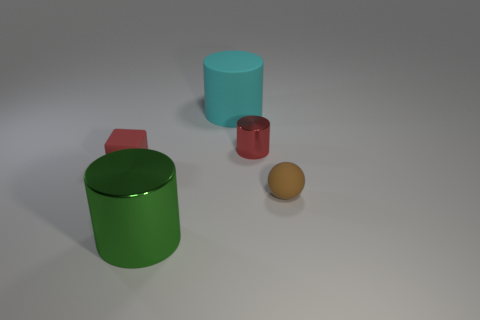Add 3 red blocks. How many objects exist? 8 Subtract all blocks. How many objects are left? 4 Subtract 0 yellow cubes. How many objects are left? 5 Subtract all red shiny things. Subtract all small metallic things. How many objects are left? 3 Add 1 rubber spheres. How many rubber spheres are left? 2 Add 4 red things. How many red things exist? 6 